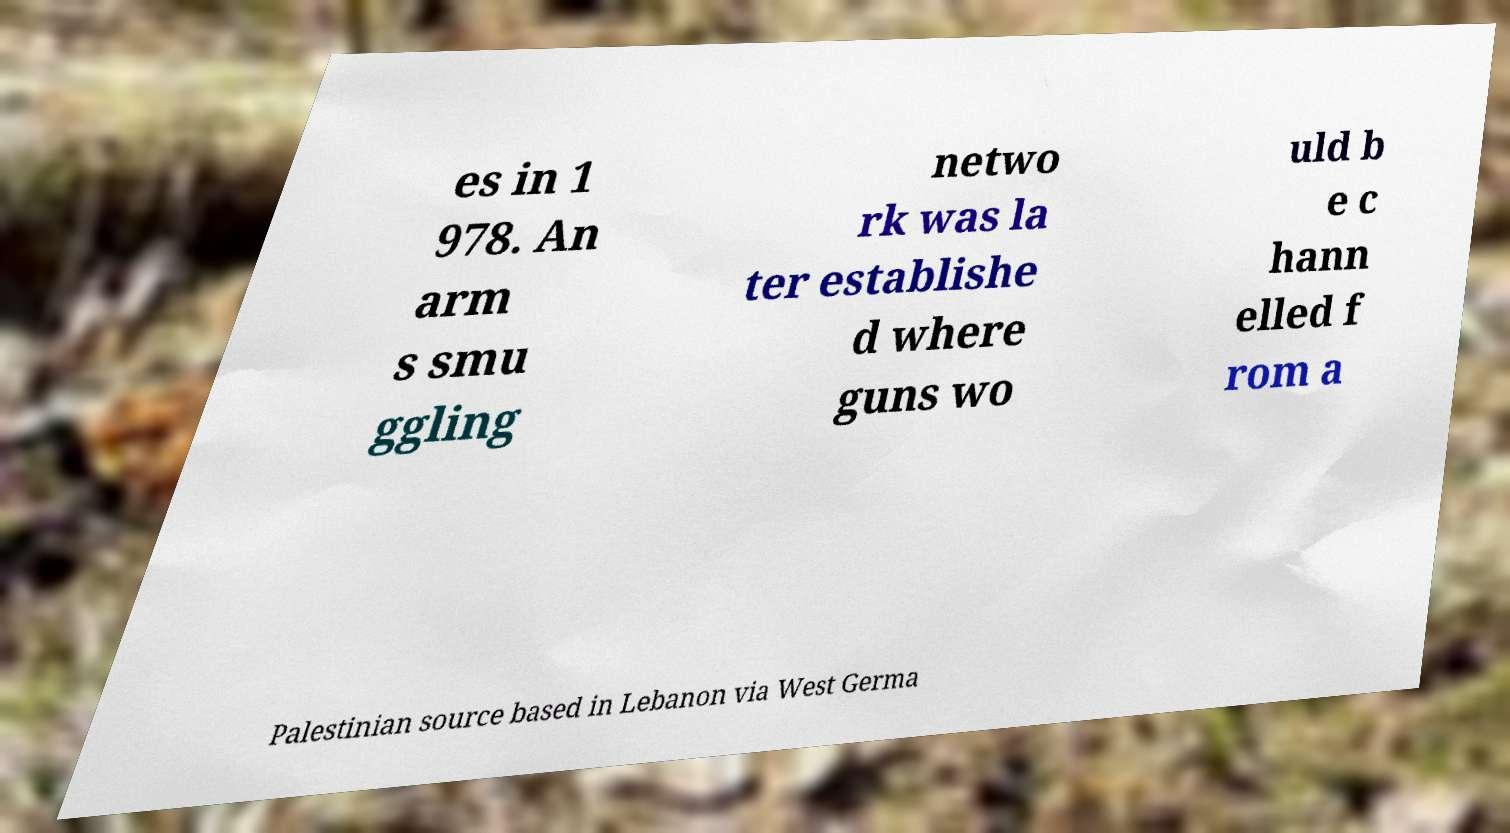I need the written content from this picture converted into text. Can you do that? es in 1 978. An arm s smu ggling netwo rk was la ter establishe d where guns wo uld b e c hann elled f rom a Palestinian source based in Lebanon via West Germa 